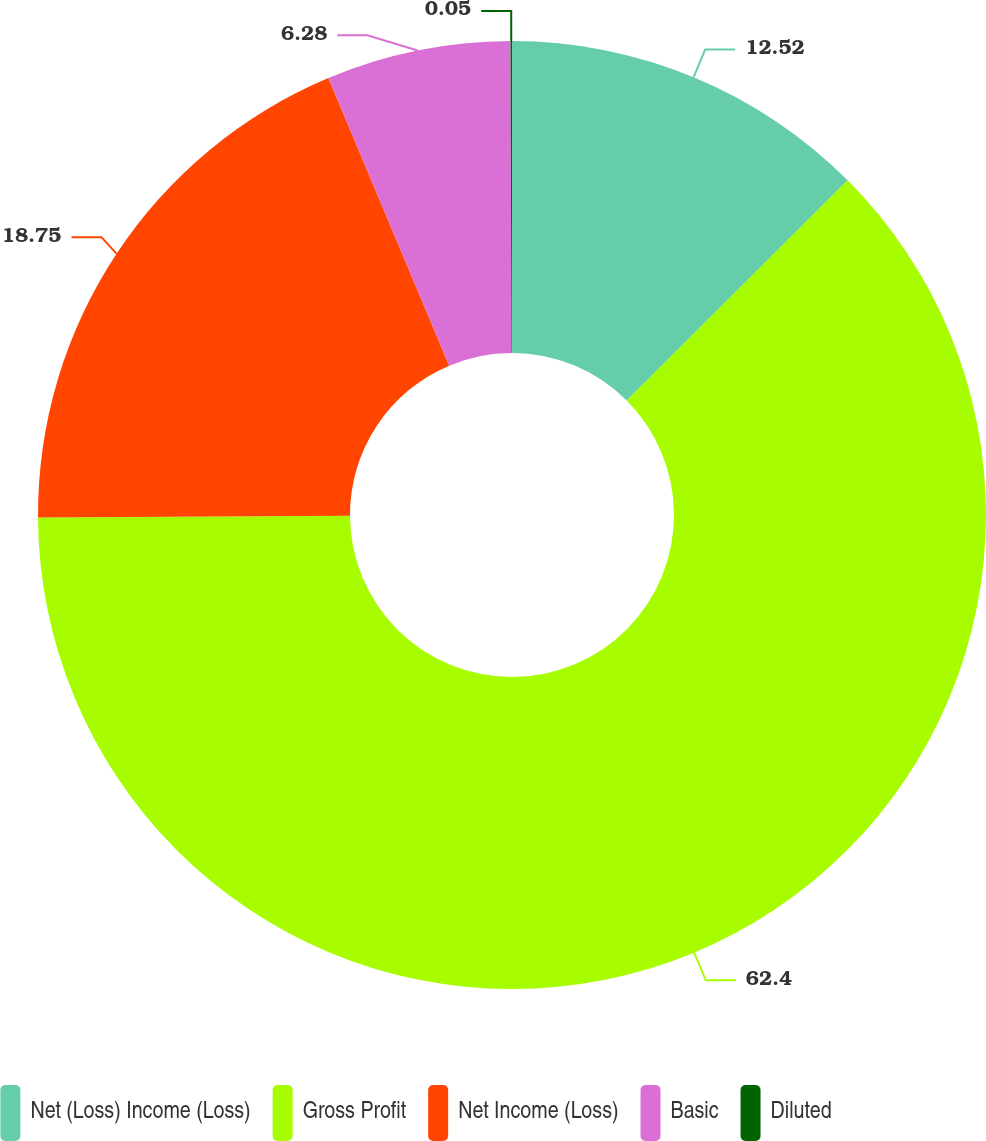Convert chart to OTSL. <chart><loc_0><loc_0><loc_500><loc_500><pie_chart><fcel>Net (Loss) Income (Loss)<fcel>Gross Profit<fcel>Net Income (Loss)<fcel>Basic<fcel>Diluted<nl><fcel>12.52%<fcel>62.39%<fcel>18.75%<fcel>6.28%<fcel>0.05%<nl></chart> 